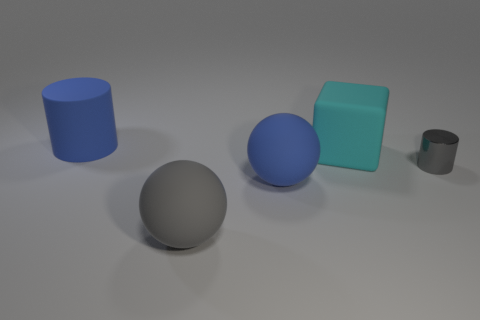What material is the sphere that is the same color as the shiny cylinder?
Your answer should be compact. Rubber. What number of objects are yellow matte cylinders or big rubber objects?
Provide a succinct answer. 4. What number of things are right of the blue rubber cylinder and left of the gray sphere?
Make the answer very short. 0. Is the number of gray rubber spheres to the right of the big rubber cube less than the number of big gray balls?
Provide a succinct answer. Yes. What shape is the blue rubber object that is the same size as the blue ball?
Your answer should be very brief. Cylinder. How many other objects are the same color as the big cylinder?
Offer a very short reply. 1. Is the size of the metal thing the same as the block?
Give a very brief answer. No. How many objects are either large yellow things or large matte things behind the metallic cylinder?
Provide a short and direct response. 2. Is the number of big gray balls that are to the left of the large gray rubber object less than the number of rubber things left of the rubber block?
Make the answer very short. Yes. How many other objects are the same material as the cyan block?
Your answer should be compact. 3. 